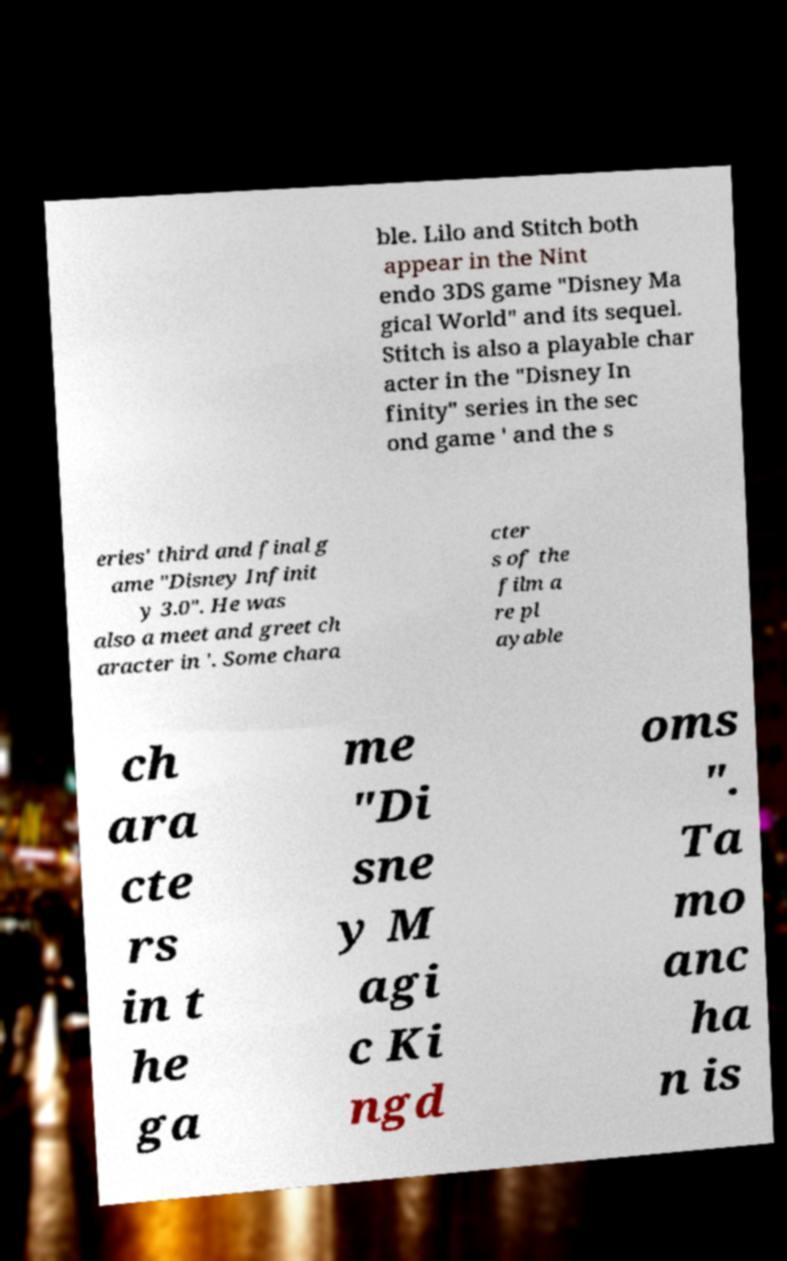For documentation purposes, I need the text within this image transcribed. Could you provide that? ble. Lilo and Stitch both appear in the Nint endo 3DS game "Disney Ma gical World" and its sequel. Stitch is also a playable char acter in the "Disney In finity" series in the sec ond game ' and the s eries' third and final g ame "Disney Infinit y 3.0". He was also a meet and greet ch aracter in '. Some chara cter s of the film a re pl ayable ch ara cte rs in t he ga me "Di sne y M agi c Ki ngd oms ". Ta mo anc ha n is 